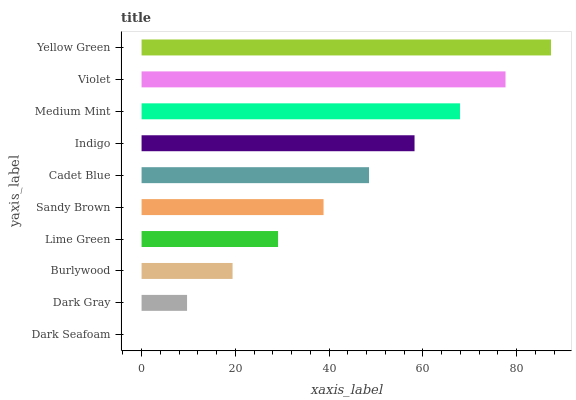Is Dark Seafoam the minimum?
Answer yes or no. Yes. Is Yellow Green the maximum?
Answer yes or no. Yes. Is Dark Gray the minimum?
Answer yes or no. No. Is Dark Gray the maximum?
Answer yes or no. No. Is Dark Gray greater than Dark Seafoam?
Answer yes or no. Yes. Is Dark Seafoam less than Dark Gray?
Answer yes or no. Yes. Is Dark Seafoam greater than Dark Gray?
Answer yes or no. No. Is Dark Gray less than Dark Seafoam?
Answer yes or no. No. Is Cadet Blue the high median?
Answer yes or no. Yes. Is Sandy Brown the low median?
Answer yes or no. Yes. Is Medium Mint the high median?
Answer yes or no. No. Is Dark Gray the low median?
Answer yes or no. No. 